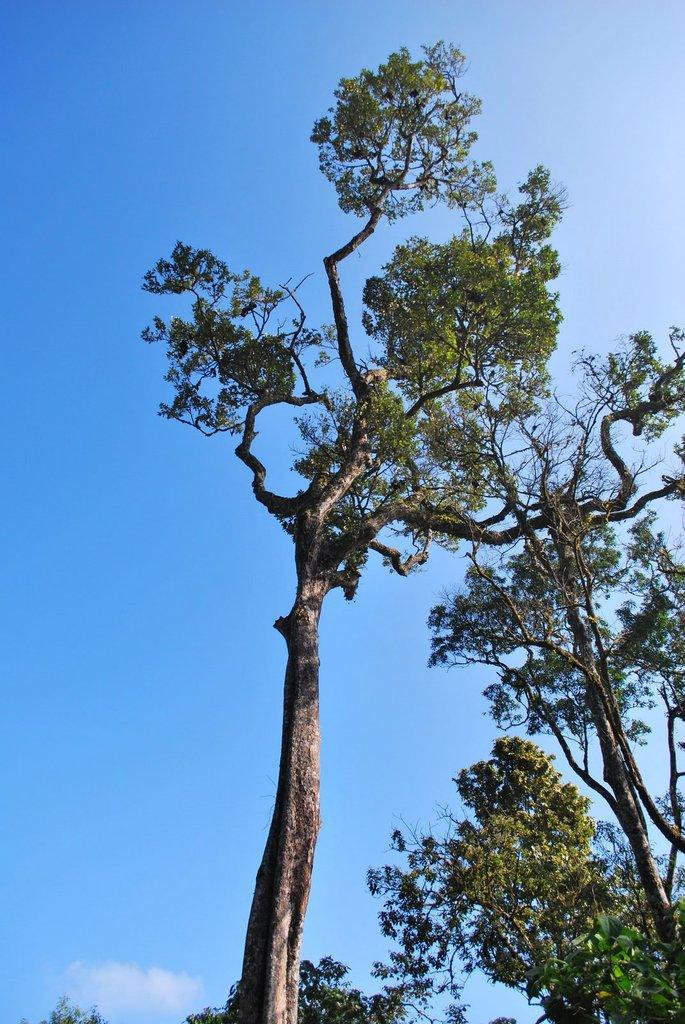What type of vegetation can be seen in the image? There are trees in the image. What part of the natural environment is visible in the image? The sky is visible in the background of the image. What type of war is being fought in the image? There is no war present in the image; it features trees and the sky. What is the condition of the heart in the image? There is no heart present in the image; it only contains trees and the sky. 